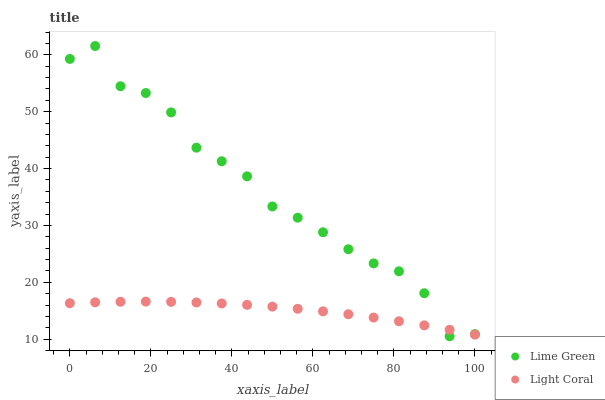Does Light Coral have the minimum area under the curve?
Answer yes or no. Yes. Does Lime Green have the maximum area under the curve?
Answer yes or no. Yes. Does Lime Green have the minimum area under the curve?
Answer yes or no. No. Is Light Coral the smoothest?
Answer yes or no. Yes. Is Lime Green the roughest?
Answer yes or no. Yes. Is Lime Green the smoothest?
Answer yes or no. No. Does Lime Green have the lowest value?
Answer yes or no. Yes. Does Lime Green have the highest value?
Answer yes or no. Yes. Does Light Coral intersect Lime Green?
Answer yes or no. Yes. Is Light Coral less than Lime Green?
Answer yes or no. No. Is Light Coral greater than Lime Green?
Answer yes or no. No. 